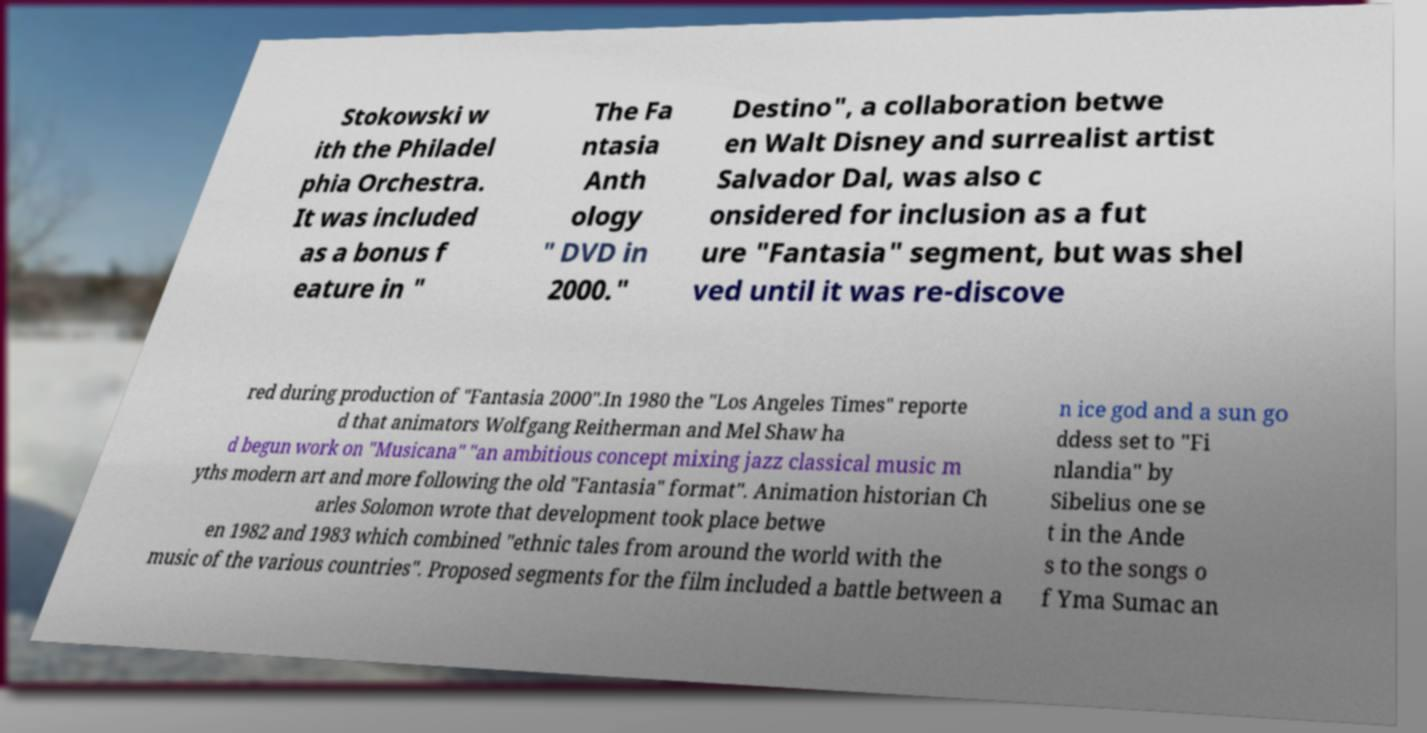Could you extract and type out the text from this image? Stokowski w ith the Philadel phia Orchestra. It was included as a bonus f eature in " The Fa ntasia Anth ology " DVD in 2000." Destino", a collaboration betwe en Walt Disney and surrealist artist Salvador Dal, was also c onsidered for inclusion as a fut ure "Fantasia" segment, but was shel ved until it was re-discove red during production of "Fantasia 2000".In 1980 the "Los Angeles Times" reporte d that animators Wolfgang Reitherman and Mel Shaw ha d begun work on "Musicana" "an ambitious concept mixing jazz classical music m yths modern art and more following the old "Fantasia" format". Animation historian Ch arles Solomon wrote that development took place betwe en 1982 and 1983 which combined "ethnic tales from around the world with the music of the various countries". Proposed segments for the film included a battle between a n ice god and a sun go ddess set to "Fi nlandia" by Sibelius one se t in the Ande s to the songs o f Yma Sumac an 